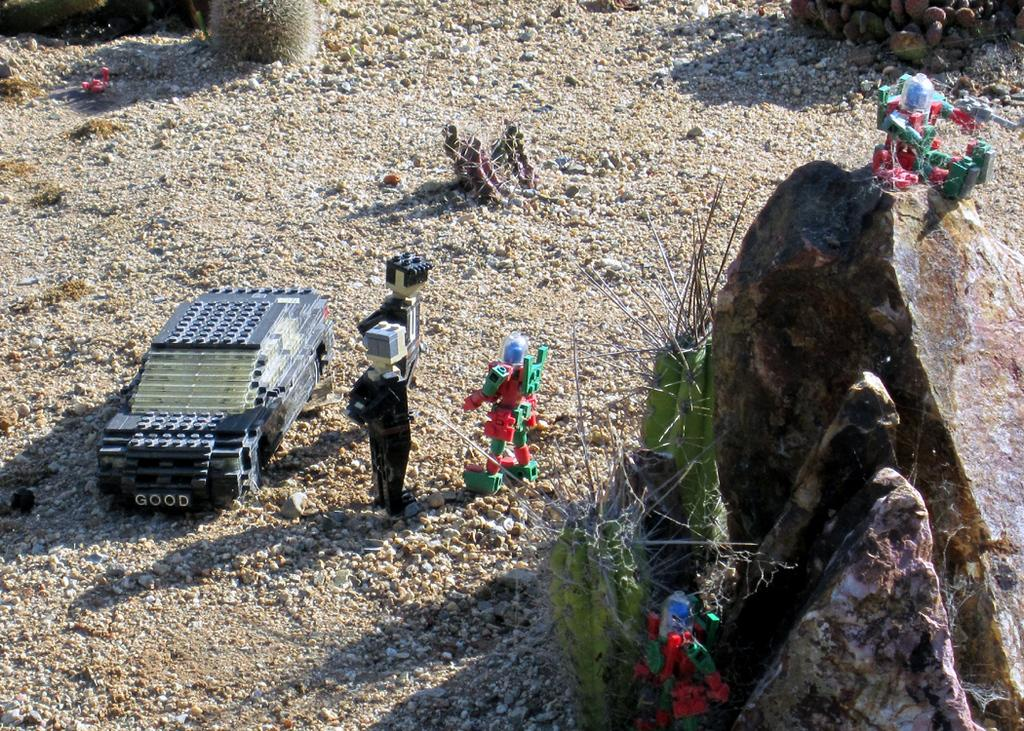What type of objects can be seen in the image? There are toys in the image. What is present at the bottom of the image? There are stones and sand at the bottom of the image. How many sisters are playing with the toys in the image? There is no mention of sisters in the image, and therefore no such information can be provided. 